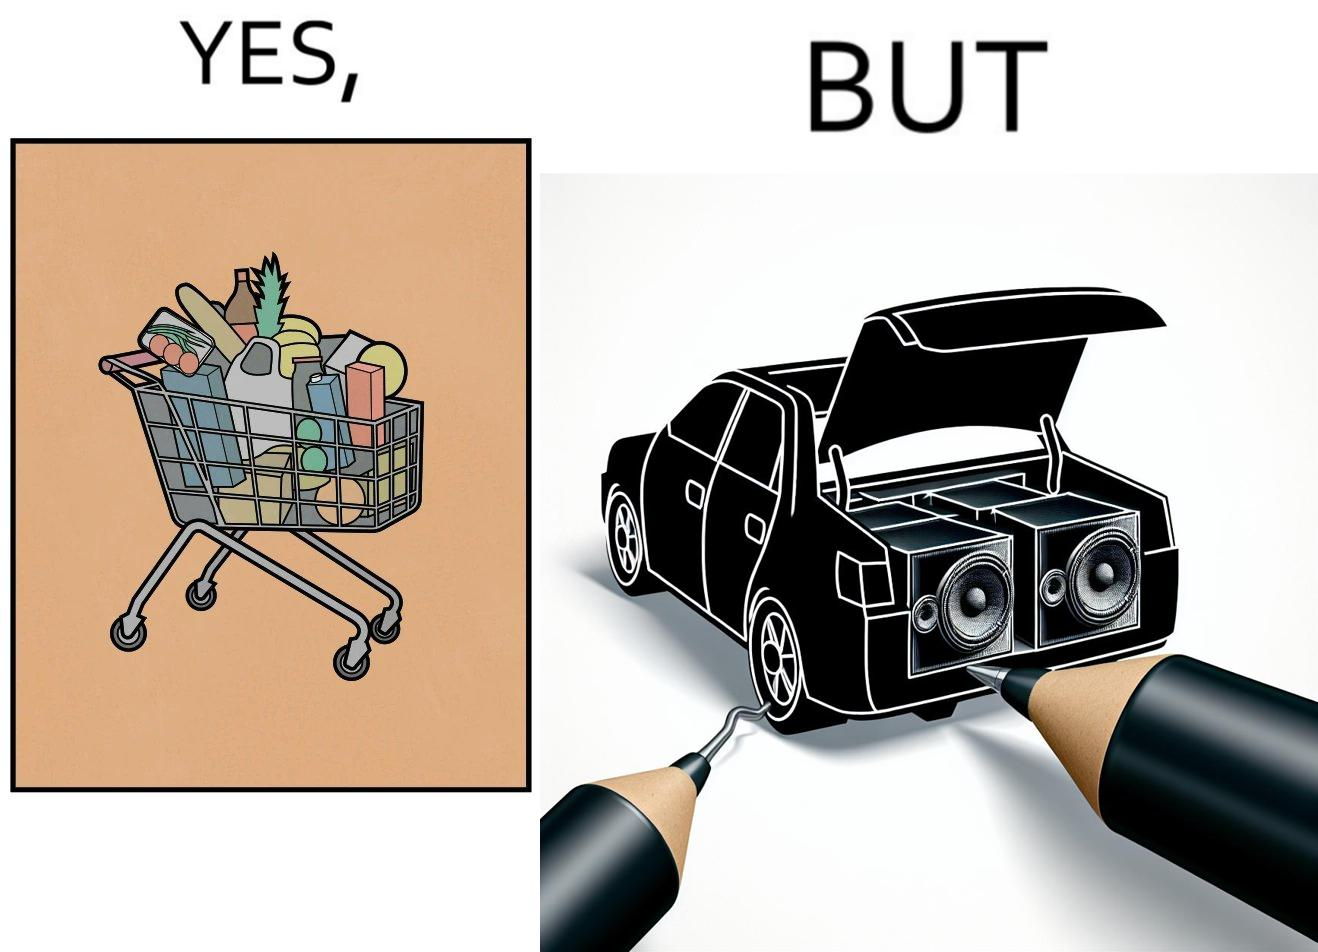Describe the satirical element in this image. The image is ironic, because a car trunk was earlier designed to keep some extra luggage or things but people nowadays get speakers installed in the trunk which in turn reduces the space in the trunk and making it difficult for people to store the extra luggage in the trunk 